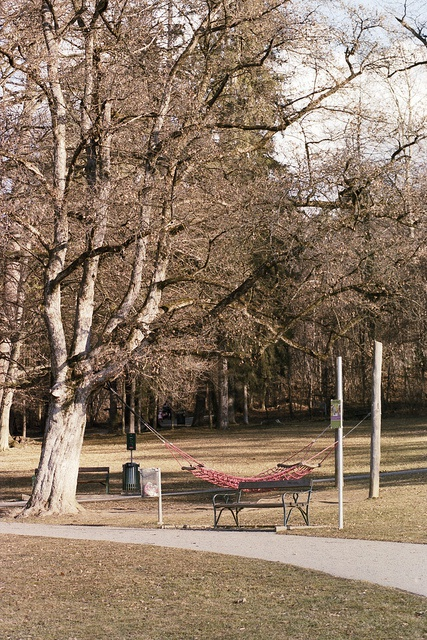Describe the objects in this image and their specific colors. I can see bench in gray and black tones, bench in gray, black, and maroon tones, bench in gray, black, and maroon tones, and bench in black and gray tones in this image. 